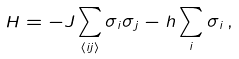<formula> <loc_0><loc_0><loc_500><loc_500>H = - J \sum _ { \langle i j \rangle } \sigma _ { i } \sigma _ { j } - h \sum _ { i } \sigma _ { i } \, ,</formula> 